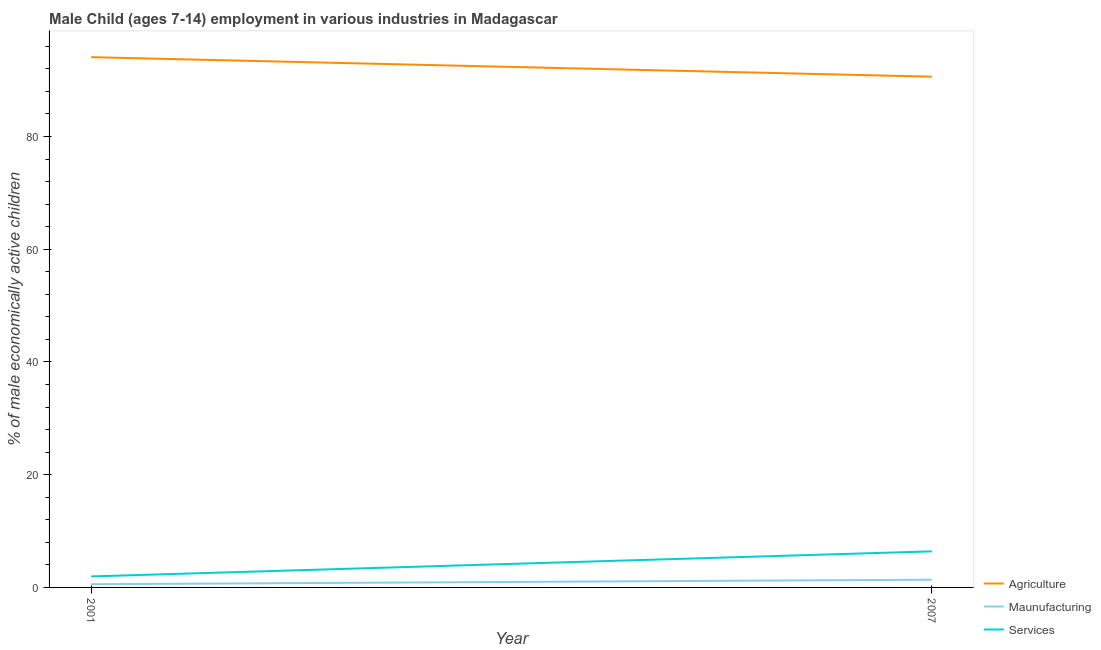How many different coloured lines are there?
Make the answer very short. 3. Does the line corresponding to percentage of economically active children in agriculture intersect with the line corresponding to percentage of economically active children in services?
Offer a very short reply. No. Is the number of lines equal to the number of legend labels?
Your answer should be very brief. Yes. What is the percentage of economically active children in agriculture in 2001?
Make the answer very short. 94.08. Across all years, what is the maximum percentage of economically active children in manufacturing?
Your answer should be compact. 1.37. Across all years, what is the minimum percentage of economically active children in manufacturing?
Ensure brevity in your answer.  0.57. In which year was the percentage of economically active children in services maximum?
Make the answer very short. 2007. What is the total percentage of economically active children in manufacturing in the graph?
Your answer should be very brief. 1.94. What is the difference between the percentage of economically active children in manufacturing in 2001 and that in 2007?
Give a very brief answer. -0.8. What is the difference between the percentage of economically active children in manufacturing in 2007 and the percentage of economically active children in agriculture in 2001?
Provide a short and direct response. -92.71. What is the average percentage of economically active children in services per year?
Your response must be concise. 4.17. In the year 2007, what is the difference between the percentage of economically active children in manufacturing and percentage of economically active children in agriculture?
Your answer should be compact. -89.25. What is the ratio of the percentage of economically active children in manufacturing in 2001 to that in 2007?
Give a very brief answer. 0.42. Is the percentage of economically active children in agriculture in 2001 less than that in 2007?
Give a very brief answer. No. Is it the case that in every year, the sum of the percentage of economically active children in agriculture and percentage of economically active children in manufacturing is greater than the percentage of economically active children in services?
Give a very brief answer. Yes. Is the percentage of economically active children in agriculture strictly greater than the percentage of economically active children in services over the years?
Provide a succinct answer. Yes. How many lines are there?
Make the answer very short. 3. Are the values on the major ticks of Y-axis written in scientific E-notation?
Provide a succinct answer. No. Does the graph contain grids?
Give a very brief answer. No. How many legend labels are there?
Your response must be concise. 3. What is the title of the graph?
Offer a very short reply. Male Child (ages 7-14) employment in various industries in Madagascar. Does "Gaseous fuel" appear as one of the legend labels in the graph?
Provide a short and direct response. No. What is the label or title of the Y-axis?
Offer a very short reply. % of male economically active children. What is the % of male economically active children in Agriculture in 2001?
Provide a succinct answer. 94.08. What is the % of male economically active children of Maunufacturing in 2001?
Make the answer very short. 0.57. What is the % of male economically active children of Services in 2001?
Provide a succinct answer. 1.95. What is the % of male economically active children in Agriculture in 2007?
Your answer should be compact. 90.62. What is the % of male economically active children of Maunufacturing in 2007?
Offer a terse response. 1.37. What is the % of male economically active children in Services in 2007?
Your answer should be compact. 6.4. Across all years, what is the maximum % of male economically active children of Agriculture?
Offer a very short reply. 94.08. Across all years, what is the maximum % of male economically active children in Maunufacturing?
Ensure brevity in your answer.  1.37. Across all years, what is the minimum % of male economically active children in Agriculture?
Offer a very short reply. 90.62. Across all years, what is the minimum % of male economically active children in Maunufacturing?
Offer a very short reply. 0.57. Across all years, what is the minimum % of male economically active children in Services?
Make the answer very short. 1.95. What is the total % of male economically active children of Agriculture in the graph?
Ensure brevity in your answer.  184.7. What is the total % of male economically active children in Maunufacturing in the graph?
Offer a very short reply. 1.94. What is the total % of male economically active children of Services in the graph?
Offer a terse response. 8.35. What is the difference between the % of male economically active children of Agriculture in 2001 and that in 2007?
Offer a terse response. 3.46. What is the difference between the % of male economically active children in Maunufacturing in 2001 and that in 2007?
Your response must be concise. -0.8. What is the difference between the % of male economically active children of Services in 2001 and that in 2007?
Make the answer very short. -4.45. What is the difference between the % of male economically active children in Agriculture in 2001 and the % of male economically active children in Maunufacturing in 2007?
Offer a terse response. 92.71. What is the difference between the % of male economically active children in Agriculture in 2001 and the % of male economically active children in Services in 2007?
Offer a terse response. 87.68. What is the difference between the % of male economically active children in Maunufacturing in 2001 and the % of male economically active children in Services in 2007?
Provide a succinct answer. -5.83. What is the average % of male economically active children of Agriculture per year?
Make the answer very short. 92.35. What is the average % of male economically active children of Maunufacturing per year?
Ensure brevity in your answer.  0.97. What is the average % of male economically active children of Services per year?
Offer a very short reply. 4.17. In the year 2001, what is the difference between the % of male economically active children of Agriculture and % of male economically active children of Maunufacturing?
Offer a very short reply. 93.51. In the year 2001, what is the difference between the % of male economically active children of Agriculture and % of male economically active children of Services?
Provide a succinct answer. 92.13. In the year 2001, what is the difference between the % of male economically active children in Maunufacturing and % of male economically active children in Services?
Your answer should be very brief. -1.38. In the year 2007, what is the difference between the % of male economically active children in Agriculture and % of male economically active children in Maunufacturing?
Provide a succinct answer. 89.25. In the year 2007, what is the difference between the % of male economically active children of Agriculture and % of male economically active children of Services?
Keep it short and to the point. 84.22. In the year 2007, what is the difference between the % of male economically active children of Maunufacturing and % of male economically active children of Services?
Your response must be concise. -5.03. What is the ratio of the % of male economically active children of Agriculture in 2001 to that in 2007?
Your answer should be compact. 1.04. What is the ratio of the % of male economically active children of Maunufacturing in 2001 to that in 2007?
Keep it short and to the point. 0.42. What is the ratio of the % of male economically active children of Services in 2001 to that in 2007?
Ensure brevity in your answer.  0.3. What is the difference between the highest and the second highest % of male economically active children of Agriculture?
Ensure brevity in your answer.  3.46. What is the difference between the highest and the second highest % of male economically active children in Maunufacturing?
Offer a terse response. 0.8. What is the difference between the highest and the second highest % of male economically active children of Services?
Give a very brief answer. 4.45. What is the difference between the highest and the lowest % of male economically active children in Agriculture?
Give a very brief answer. 3.46. What is the difference between the highest and the lowest % of male economically active children in Maunufacturing?
Your answer should be compact. 0.8. What is the difference between the highest and the lowest % of male economically active children of Services?
Your answer should be compact. 4.45. 